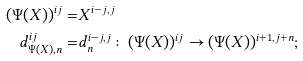Convert formula to latex. <formula><loc_0><loc_0><loc_500><loc_500>( \Psi ( X ) ) ^ { i j } = & X ^ { i - j , j } \\ d _ { \Psi ( X ) , n } ^ { i j } = & d _ { n } ^ { i - j , j } \colon ( \Psi ( X ) ) ^ { i j } \to ( \Psi ( X ) ) ^ { i + 1 , j + n } ;</formula> 